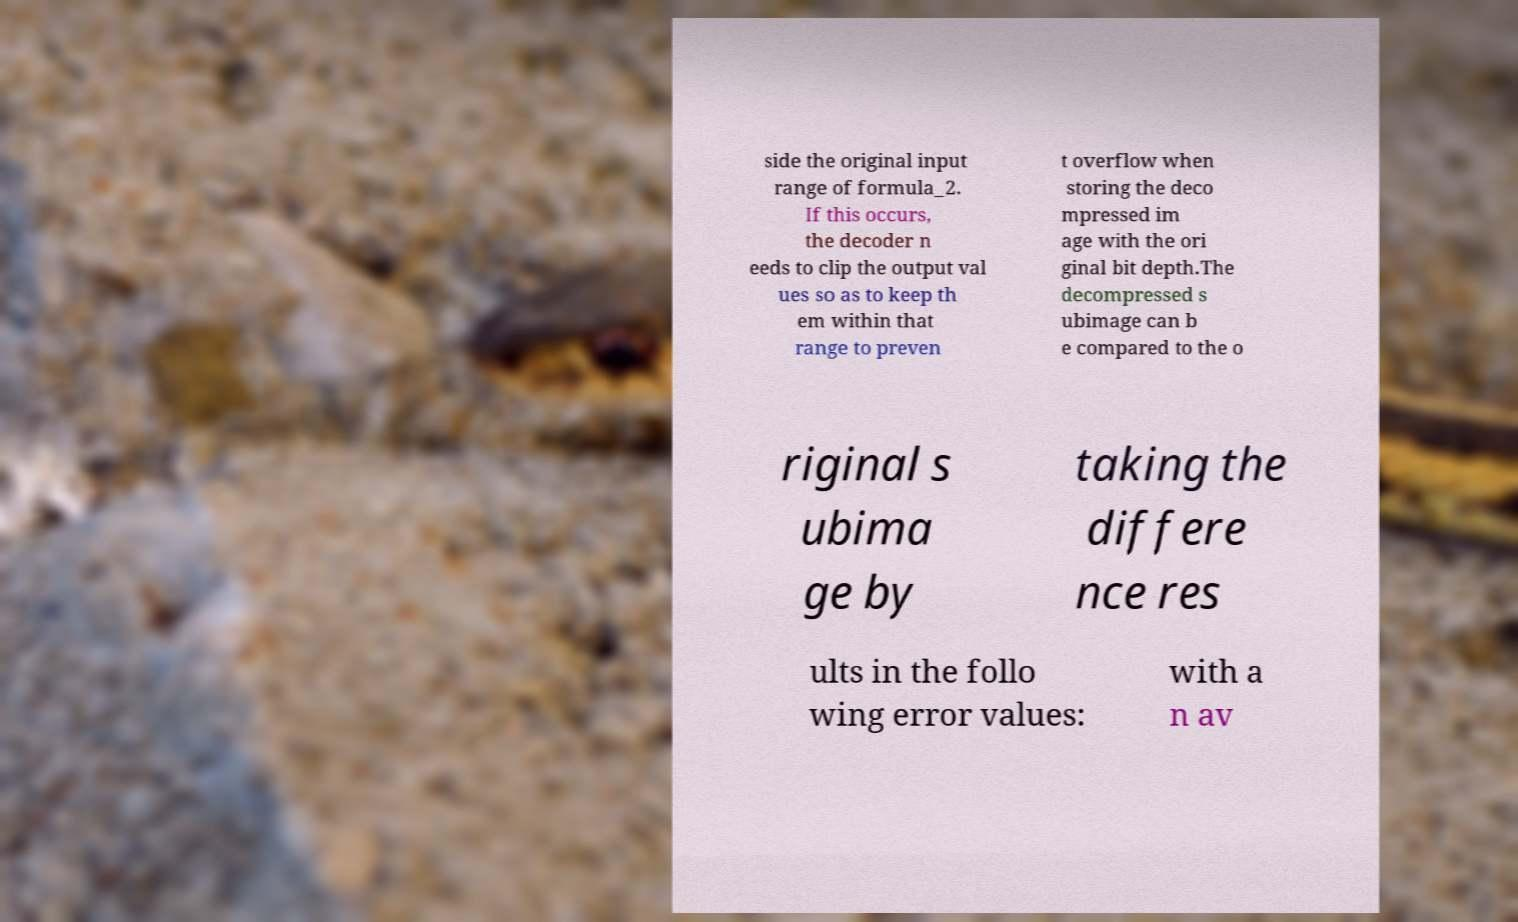Please read and relay the text visible in this image. What does it say? side the original input range of formula_2. If this occurs, the decoder n eeds to clip the output val ues so as to keep th em within that range to preven t overflow when storing the deco mpressed im age with the ori ginal bit depth.The decompressed s ubimage can b e compared to the o riginal s ubima ge by taking the differe nce res ults in the follo wing error values: with a n av 